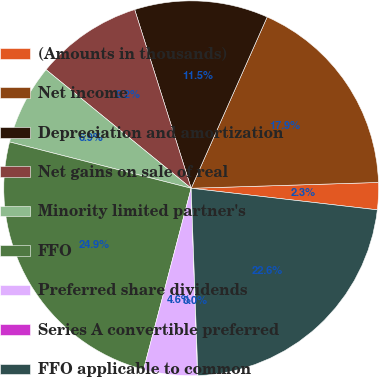Convert chart to OTSL. <chart><loc_0><loc_0><loc_500><loc_500><pie_chart><fcel>(Amounts in thousands)<fcel>Net income<fcel>Depreciation and amortization<fcel>Net gains on sale of real<fcel>Minority limited partner's<fcel>FFO<fcel>Preferred share dividends<fcel>Series A convertible preferred<fcel>FFO applicable to common<nl><fcel>2.33%<fcel>17.86%<fcel>11.52%<fcel>9.22%<fcel>6.93%<fcel>24.89%<fcel>4.63%<fcel>0.03%<fcel>22.59%<nl></chart> 